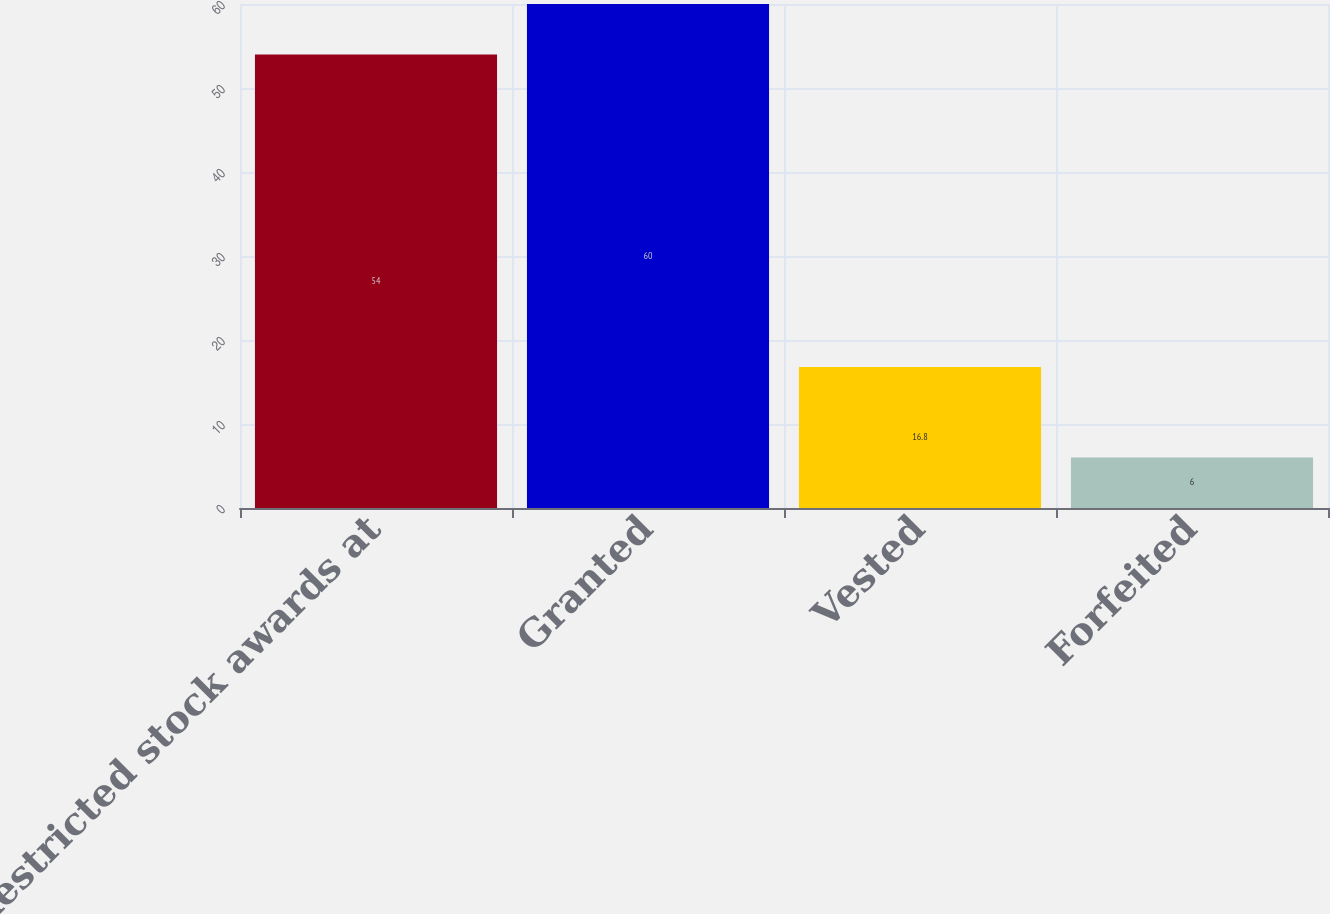Convert chart. <chart><loc_0><loc_0><loc_500><loc_500><bar_chart><fcel>Restricted stock awards at<fcel>Granted<fcel>Vested<fcel>Forfeited<nl><fcel>54<fcel>60<fcel>16.8<fcel>6<nl></chart> 